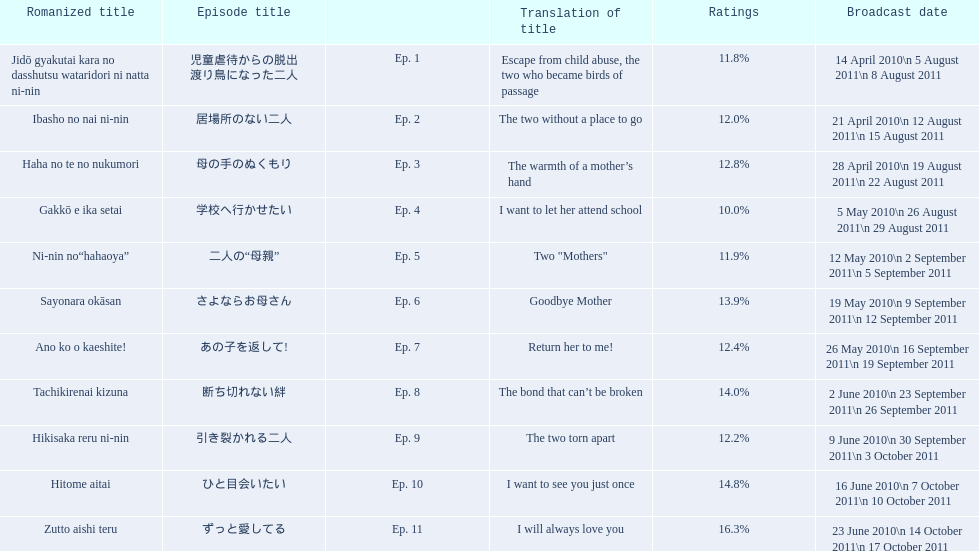What were all the episode titles for the show mother? 児童虐待からの脱出 渡り鳥になった二人, 居場所のない二人, 母の手のぬくもり, 学校へ行かせたい, 二人の“母親”, さよならお母さん, あの子を返して!, 断ち切れない絆, 引き裂かれる二人, ひと目会いたい, ずっと愛してる. What were all the translated episode titles for the show mother? Escape from child abuse, the two who became birds of passage, The two without a place to go, The warmth of a mother’s hand, I want to let her attend school, Two "Mothers", Goodbye Mother, Return her to me!, The bond that can’t be broken, The two torn apart, I want to see you just once, I will always love you. Which episode was translated to i want to let her attend school? Ep. 4. 